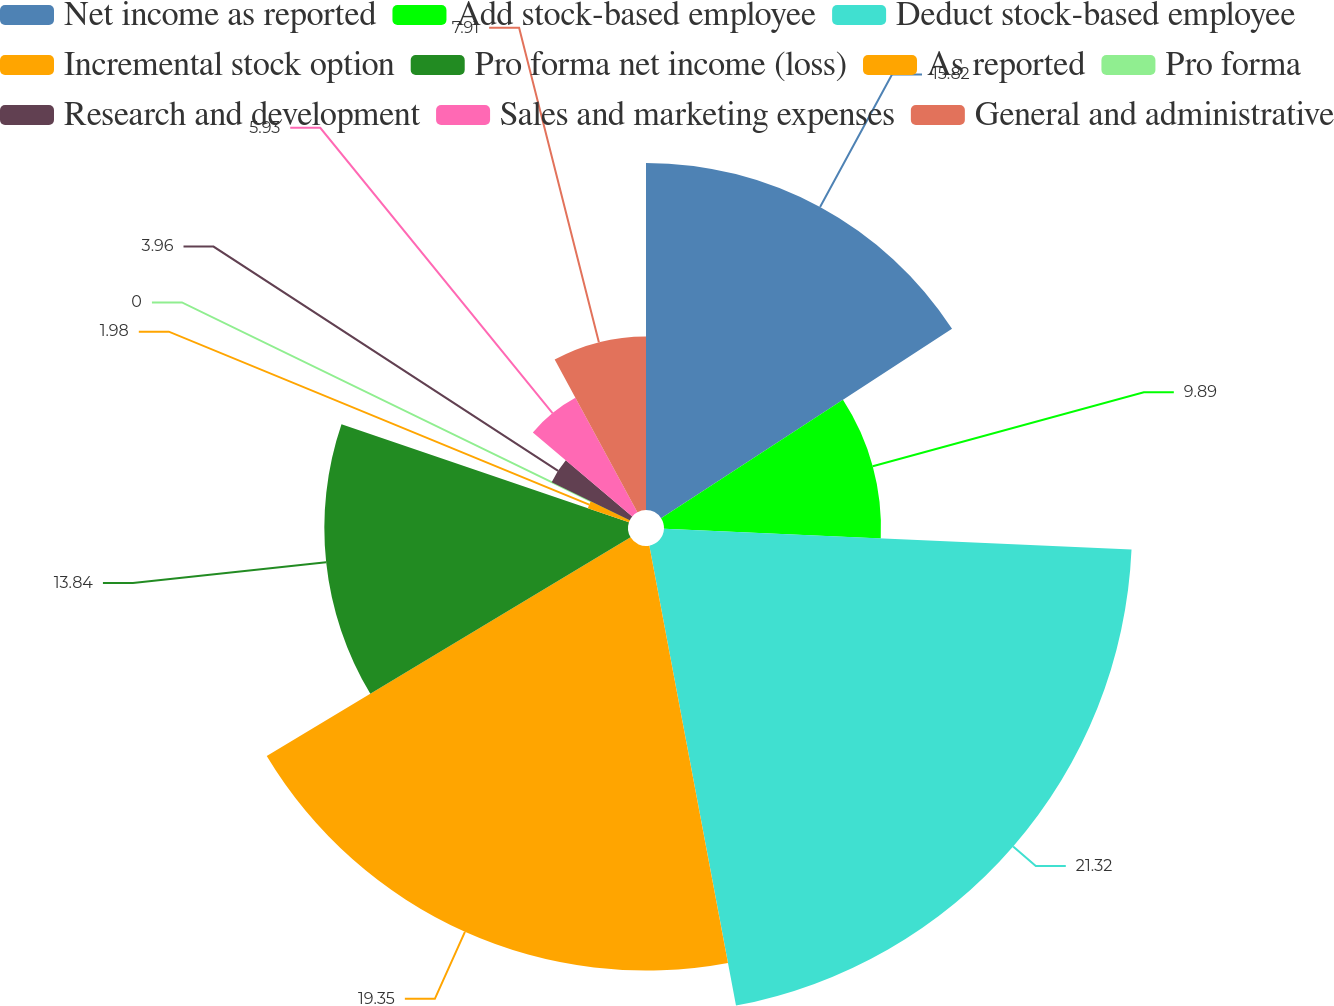Convert chart to OTSL. <chart><loc_0><loc_0><loc_500><loc_500><pie_chart><fcel>Net income as reported<fcel>Add stock-based employee<fcel>Deduct stock-based employee<fcel>Incremental stock option<fcel>Pro forma net income (loss)<fcel>As reported<fcel>Pro forma<fcel>Research and development<fcel>Sales and marketing expenses<fcel>General and administrative<nl><fcel>15.82%<fcel>9.89%<fcel>21.33%<fcel>19.35%<fcel>13.84%<fcel>1.98%<fcel>0.0%<fcel>3.96%<fcel>5.93%<fcel>7.91%<nl></chart> 